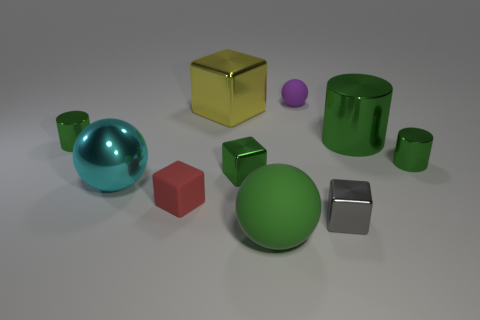Subtract all balls. How many objects are left? 7 Add 4 red cubes. How many red cubes are left? 5 Add 9 green matte things. How many green matte things exist? 10 Subtract 0 purple cubes. How many objects are left? 10 Subtract all large green metallic things. Subtract all metallic spheres. How many objects are left? 8 